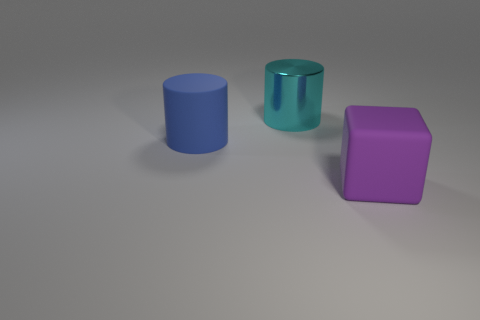Are there any other large metallic cylinders of the same color as the large metal cylinder?
Your answer should be compact. No. How many small things are cyan matte cylinders or cylinders?
Offer a very short reply. 0. How many big cyan objects are there?
Provide a short and direct response. 1. What is the material of the big thing on the left side of the cyan cylinder?
Provide a succinct answer. Rubber. Are there any cyan metal things in front of the cyan metallic thing?
Your answer should be compact. No. Do the blue cylinder and the cyan thing have the same size?
Provide a succinct answer. Yes. How many blue objects are the same material as the big purple thing?
Your answer should be compact. 1. How big is the thing that is behind the big cylinder that is in front of the metallic cylinder?
Your response must be concise. Large. The object that is both in front of the cyan metallic thing and to the left of the big block is what color?
Provide a short and direct response. Blue. Is the shape of the large cyan object the same as the blue rubber thing?
Your answer should be very brief. Yes. 